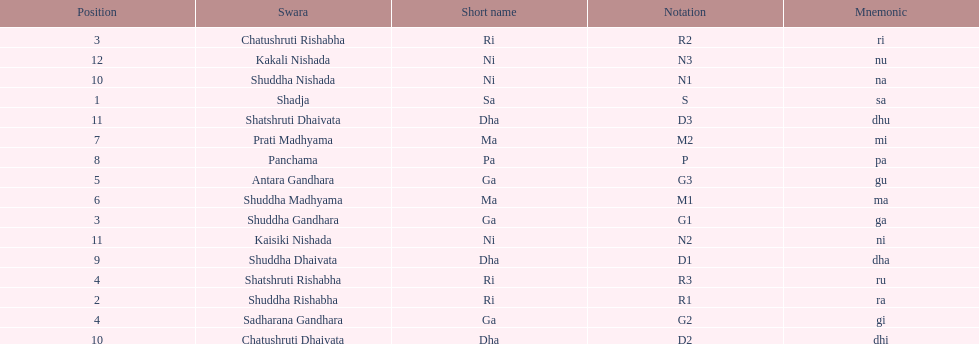What is the total number of positions listed? 16. 